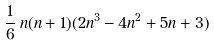<formula> <loc_0><loc_0><loc_500><loc_500>\frac { 1 } { 6 } \, n ( n + 1 ) ( 2 n ^ { 3 } - 4 n ^ { 2 } + 5 n + 3 )</formula> 